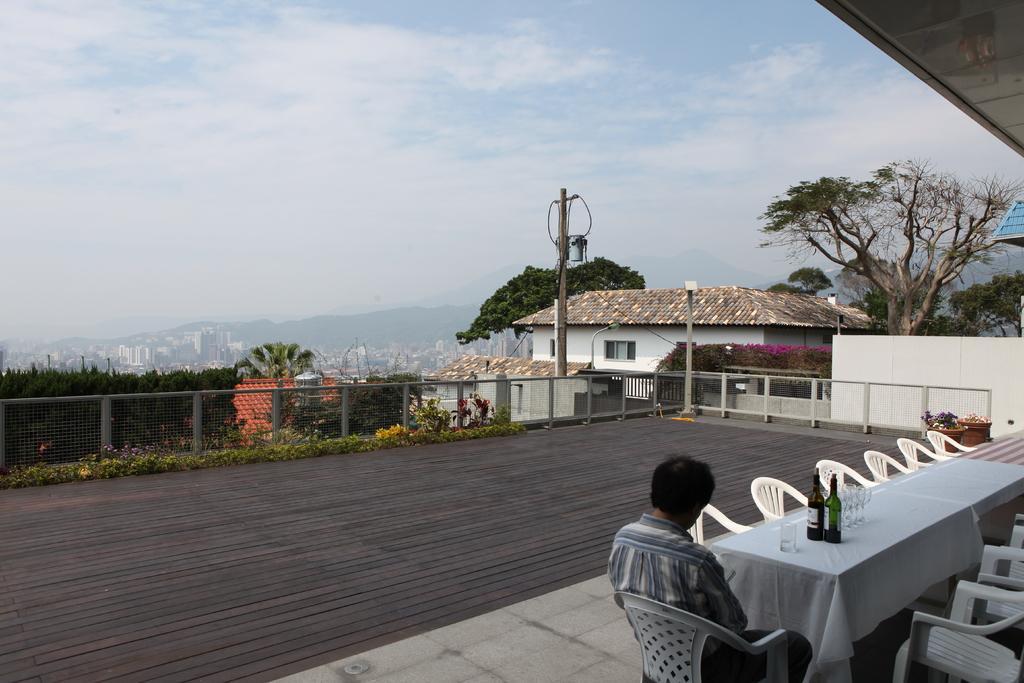Please provide a concise description of this image. This is picture taken in the outdoor, the man is sitting in the white chair and the table is covered with a white cloth on top of the table there is a two wine bottle and the wine glass. This is a wooden floor on the wooden floor there are the plants. On the wooden floor can see the top view of the city. This is a electrical pole. This is a sky with clouds. 